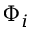Convert formula to latex. <formula><loc_0><loc_0><loc_500><loc_500>\Phi _ { i }</formula> 